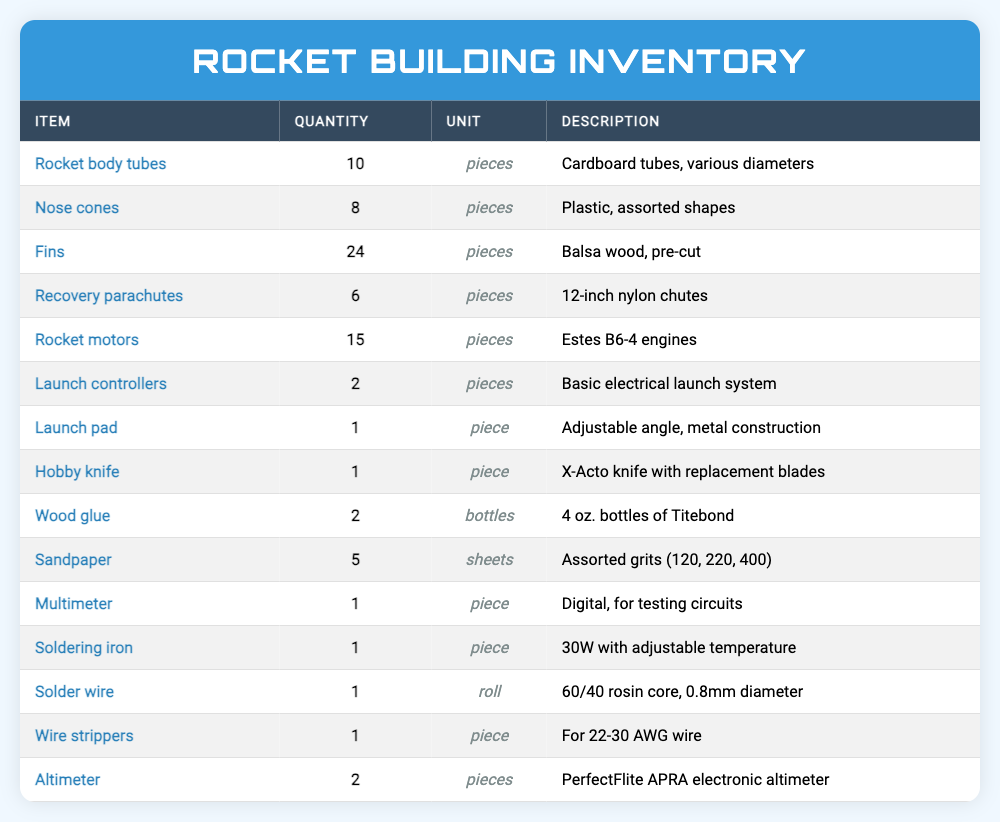What is the total quantity of rocket motors available? There are 15 rocket motors listed in the inventory.
Answer: 15 How many different types of rocket body tubes are there? The inventory lists only one type of rocket body tubes, described as cardboard tubes of various diameters.
Answer: 1 Is there more than one nose cone available? Yes, there are 8 nose cones available, which indicates multiple pieces.
Answer: Yes What is the combined quantity of recovery parachutes and rocket motors? The quantity of recovery parachutes is 6 and the quantity of rocket motors is 15. Adding these together gives 6 + 15 = 21.
Answer: 21 Which item has the highest quantity in the inventory? The fins have the highest quantity with 24 pieces listed.
Answer: Fins How many items in the inventory are used specifically for electrical tasks? There are 3 items (multimeter, soldering iron, and wire strippers) that are specifically for electrical tasks.
Answer: 3 What is the total number of items available in the inventory? By adding all the quantities together: 10 (body tubes) + 8 (nose cones) + 24 (fins) + 6 (parachutes) + 15 (motors) + 2 (launch controllers) + 1 (launch pad) + 1 (hobby knife) + 2 (wood glue) + 5 (sandpaper) + 1 (multimeter) + 1 (soldering iron) + 1 (solder wire) + 1 (wire strippers) + 2 (altimeters) = 78.
Answer: 78 Are there any items that require assembly before use? Yes, items like the rocket body tubes, fins, and nose cones typically require assembly before they can be used in a rocket.
Answer: Yes How many fewer launch controllers are there compared to rocket motors? There are 15 rocket motors and 2 launch controllers. The difference is 15 - 2 = 13.
Answer: 13 What type of wood is used for the fins? The fins are made from balsa wood.
Answer: Balsa wood How many items are listed as "pieces" in the inventory? Counting the items labeled as "pieces": rocket body tubes (10), nose cones (8), fins (24), recovery parachutes (6), rocket motors (15), launch controllers (2), launch pad (1), hobby knife (1), altimeter (2). This totals to 10 + 8 + 24 + 6 + 15 + 2 + 1 + 1 + 2 = 69 pieces.
Answer: 69 